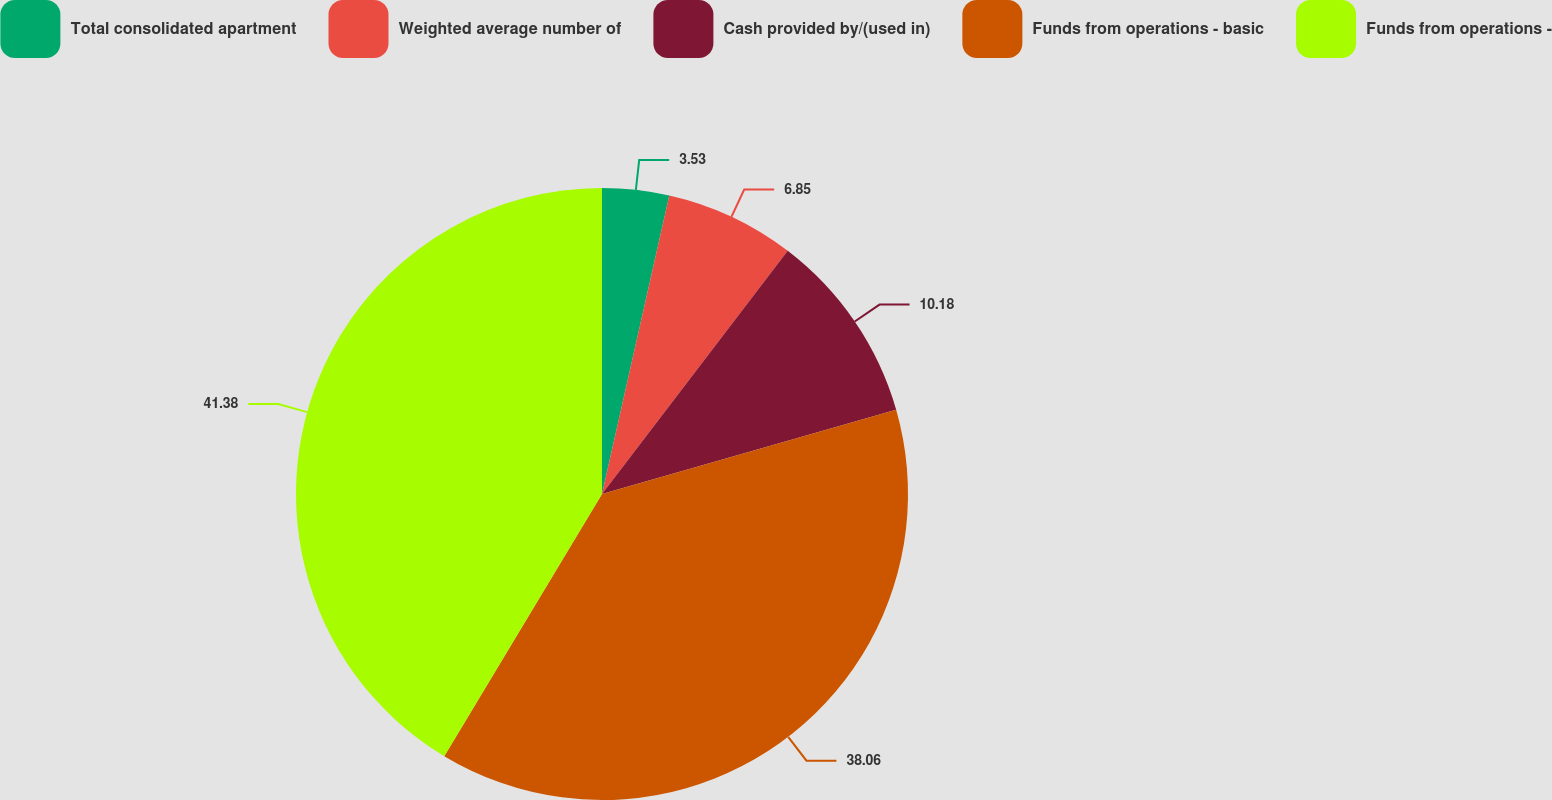Convert chart. <chart><loc_0><loc_0><loc_500><loc_500><pie_chart><fcel>Total consolidated apartment<fcel>Weighted average number of<fcel>Cash provided by/(used in)<fcel>Funds from operations - basic<fcel>Funds from operations -<nl><fcel>3.53%<fcel>6.85%<fcel>10.18%<fcel>38.06%<fcel>41.38%<nl></chart> 